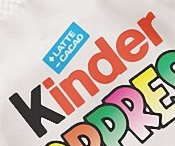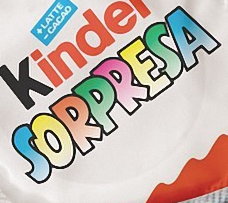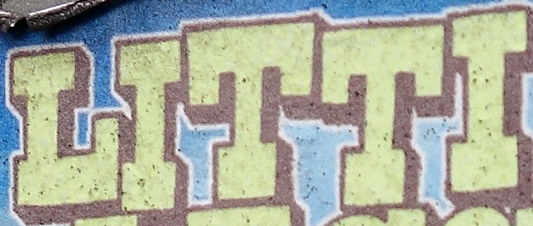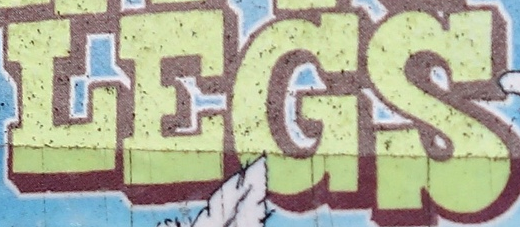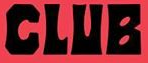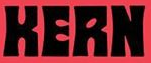Read the text from these images in sequence, separated by a semicolon. Kinder; SORPRESA; LITTI; LEGS; CLUB; KERN 